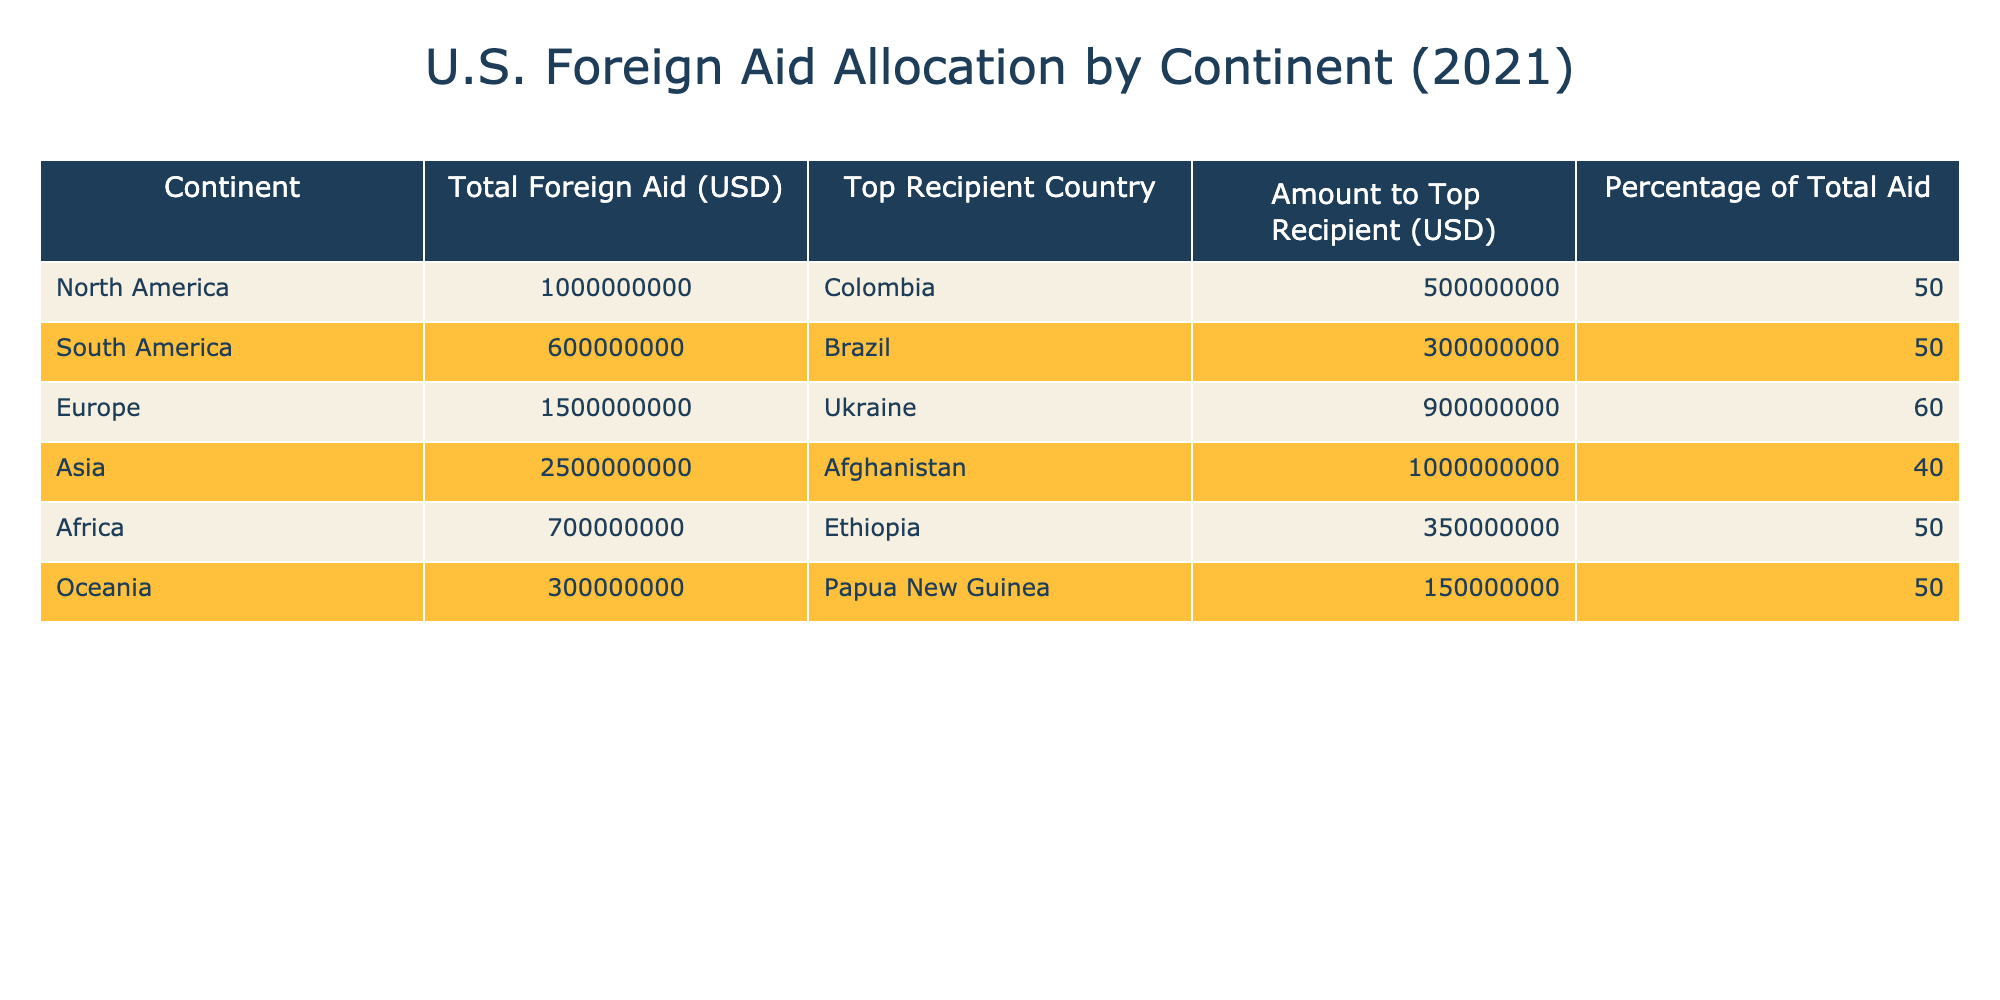What was the total foreign aid allocated to Africa in 2021? The table states that the total foreign aid allocated to Africa is listed directly under the "Total Foreign Aid (USD)" column for Africa, which shows the amount as 700,000,000.
Answer: 700,000,000 Which continent received the highest total foreign aid in 2021? By comparing the total foreign aid amounts listed in the table, Asia has the highest total at 2,500,000,000, which exceeds the amounts for all other continents.
Answer: Asia What percentage of the total foreign aid to Asia was allocated to Afghanistan? According to the table, the amount to Afghanistan is 1,000,000,000, and this represents 40% of Asia's total foreign aid of 2,500,000,000. Calculating this involves confirming that 1,000,000,000 is indeed 40% of 2,500,000,000. Confirming this leads us to confirm the given percentage is accurate.
Answer: 40.0 Did Europe receive more foreign aid than South America in 2021? The table shows Europe received a total of 1,500,000,000 while South America received 600,000,000. Since 1,500,000,000 is greater than 600,000,000, the answer is yes.
Answer: Yes What is the average foreign aid amount allocated to each continent listed in the table? There are six continents listed: North America, South America, Europe, Asia, Africa, and Oceania. The total foreign aid across all continents is 1,000,000,000 + 600,000,000 + 1,500,000,000 + 2,500,000,000 + 700,000,000 + 300,000,000 = 6,600,000,000. To find the average, we divide this total by the number of continents, which is 6, resulting in an average of 6,600,000,000 / 6 = 1,100,000,000.
Answer: 1,100,000,000 Which continent received aid directed toward a country with the highest percentage of total aid? Reviewing the "Percentage of Total Aid" column, Europe with Ukraine received 60.0%, which is the highest percentage compared to the other continents listed, where no other continent's top recipient reached such a percentage.
Answer: Europe 